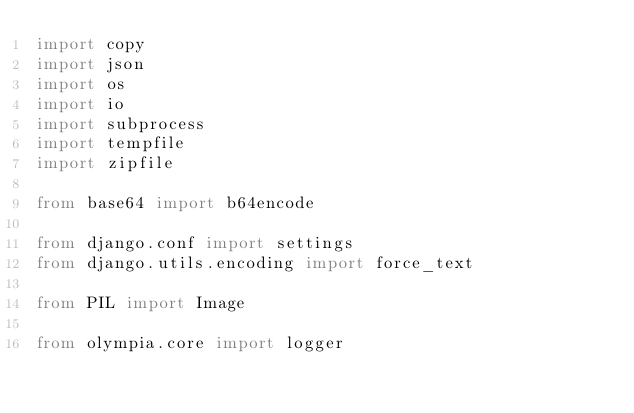Convert code to text. <code><loc_0><loc_0><loc_500><loc_500><_Python_>import copy
import json
import os
import io
import subprocess
import tempfile
import zipfile

from base64 import b64encode

from django.conf import settings
from django.utils.encoding import force_text

from PIL import Image

from olympia.core import logger</code> 